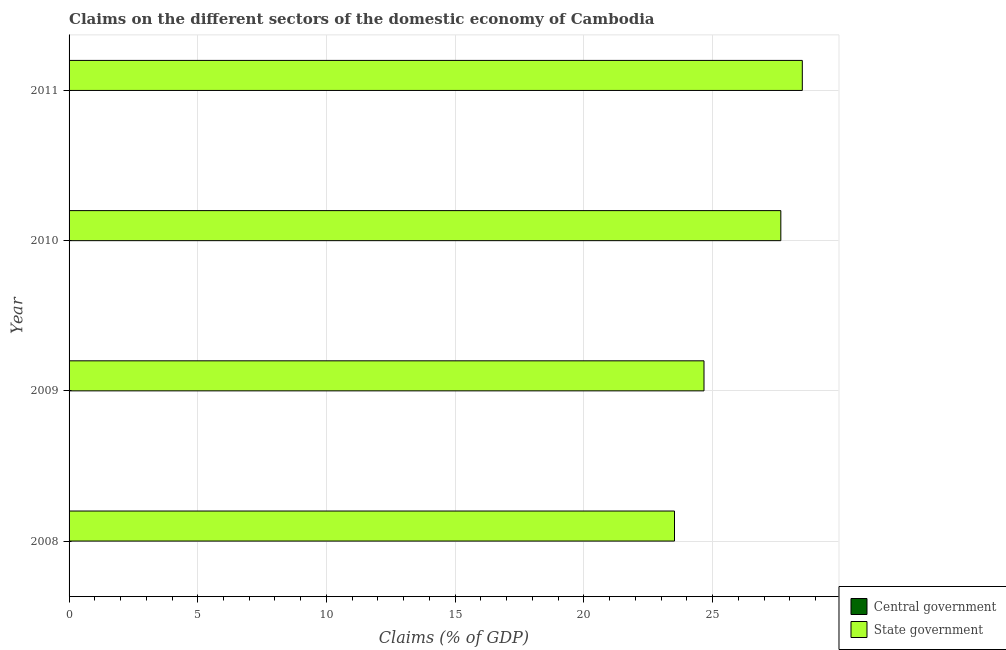What is the claims on central government in 2011?
Your answer should be very brief. 0. Across all years, what is the maximum claims on state government?
Offer a very short reply. 28.49. Across all years, what is the minimum claims on state government?
Your answer should be compact. 23.52. What is the total claims on central government in the graph?
Offer a very short reply. 0. What is the difference between the claims on state government in 2008 and that in 2009?
Ensure brevity in your answer.  -1.15. What is the difference between the claims on state government in 2009 and the claims on central government in 2008?
Keep it short and to the point. 24.67. What is the average claims on state government per year?
Ensure brevity in your answer.  26.08. What is the ratio of the claims on state government in 2008 to that in 2010?
Give a very brief answer. 0.85. Is the claims on state government in 2008 less than that in 2009?
Keep it short and to the point. Yes. What is the difference between the highest and the second highest claims on state government?
Keep it short and to the point. 0.83. What is the difference between the highest and the lowest claims on state government?
Your answer should be very brief. 4.97. Is the sum of the claims on state government in 2008 and 2009 greater than the maximum claims on central government across all years?
Keep it short and to the point. Yes. How many bars are there?
Your answer should be very brief. 4. Are all the bars in the graph horizontal?
Provide a succinct answer. Yes. Does the graph contain any zero values?
Keep it short and to the point. Yes. Does the graph contain grids?
Provide a succinct answer. Yes. How many legend labels are there?
Keep it short and to the point. 2. How are the legend labels stacked?
Keep it short and to the point. Vertical. What is the title of the graph?
Your answer should be very brief. Claims on the different sectors of the domestic economy of Cambodia. Does "Resident workers" appear as one of the legend labels in the graph?
Make the answer very short. No. What is the label or title of the X-axis?
Ensure brevity in your answer.  Claims (% of GDP). What is the Claims (% of GDP) of Central government in 2008?
Keep it short and to the point. 0. What is the Claims (% of GDP) of State government in 2008?
Your answer should be compact. 23.52. What is the Claims (% of GDP) in State government in 2009?
Provide a short and direct response. 24.67. What is the Claims (% of GDP) of Central government in 2010?
Give a very brief answer. 0. What is the Claims (% of GDP) of State government in 2010?
Your response must be concise. 27.65. What is the Claims (% of GDP) of State government in 2011?
Give a very brief answer. 28.49. Across all years, what is the maximum Claims (% of GDP) in State government?
Your answer should be very brief. 28.49. Across all years, what is the minimum Claims (% of GDP) in State government?
Give a very brief answer. 23.52. What is the total Claims (% of GDP) in Central government in the graph?
Ensure brevity in your answer.  0. What is the total Claims (% of GDP) in State government in the graph?
Provide a succinct answer. 104.33. What is the difference between the Claims (% of GDP) in State government in 2008 and that in 2009?
Offer a very short reply. -1.15. What is the difference between the Claims (% of GDP) in State government in 2008 and that in 2010?
Your answer should be very brief. -4.13. What is the difference between the Claims (% of GDP) in State government in 2008 and that in 2011?
Provide a short and direct response. -4.97. What is the difference between the Claims (% of GDP) of State government in 2009 and that in 2010?
Keep it short and to the point. -2.98. What is the difference between the Claims (% of GDP) in State government in 2009 and that in 2011?
Provide a succinct answer. -3.82. What is the difference between the Claims (% of GDP) in State government in 2010 and that in 2011?
Offer a terse response. -0.83. What is the average Claims (% of GDP) of Central government per year?
Offer a very short reply. 0. What is the average Claims (% of GDP) of State government per year?
Your answer should be very brief. 26.08. What is the ratio of the Claims (% of GDP) in State government in 2008 to that in 2009?
Make the answer very short. 0.95. What is the ratio of the Claims (% of GDP) in State government in 2008 to that in 2010?
Provide a short and direct response. 0.85. What is the ratio of the Claims (% of GDP) in State government in 2008 to that in 2011?
Keep it short and to the point. 0.83. What is the ratio of the Claims (% of GDP) in State government in 2009 to that in 2010?
Make the answer very short. 0.89. What is the ratio of the Claims (% of GDP) of State government in 2009 to that in 2011?
Give a very brief answer. 0.87. What is the ratio of the Claims (% of GDP) in State government in 2010 to that in 2011?
Keep it short and to the point. 0.97. What is the difference between the highest and the second highest Claims (% of GDP) in State government?
Offer a terse response. 0.83. What is the difference between the highest and the lowest Claims (% of GDP) in State government?
Your answer should be compact. 4.97. 